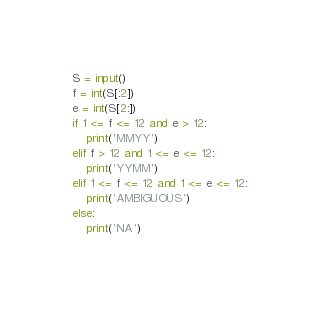Convert code to text. <code><loc_0><loc_0><loc_500><loc_500><_Python_>S = input()
f = int(S[:2])
e = int(S[2:])
if 1 <= f <= 12 and e > 12:
    print('MMYY')
elif f > 12 and 1 <= e <= 12:
    print('YYMM')
elif 1 <= f <= 12 and 1 <= e <= 12:
    print('AMBIGUOUS')
else:
    print('NA')</code> 